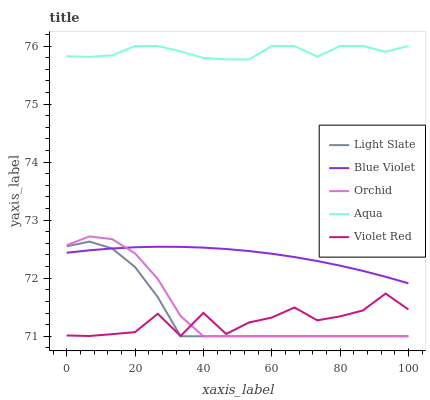Does Violet Red have the minimum area under the curve?
Answer yes or no. Yes. Does Aqua have the maximum area under the curve?
Answer yes or no. Yes. Does Aqua have the minimum area under the curve?
Answer yes or no. No. Does Violet Red have the maximum area under the curve?
Answer yes or no. No. Is Blue Violet the smoothest?
Answer yes or no. Yes. Is Violet Red the roughest?
Answer yes or no. Yes. Is Aqua the smoothest?
Answer yes or no. No. Is Aqua the roughest?
Answer yes or no. No. Does Violet Red have the lowest value?
Answer yes or no. No. Does Aqua have the highest value?
Answer yes or no. Yes. Does Violet Red have the highest value?
Answer yes or no. No. Is Light Slate less than Aqua?
Answer yes or no. Yes. Is Aqua greater than Orchid?
Answer yes or no. Yes. Does Orchid intersect Blue Violet?
Answer yes or no. Yes. Is Orchid less than Blue Violet?
Answer yes or no. No. Is Orchid greater than Blue Violet?
Answer yes or no. No. Does Light Slate intersect Aqua?
Answer yes or no. No. 